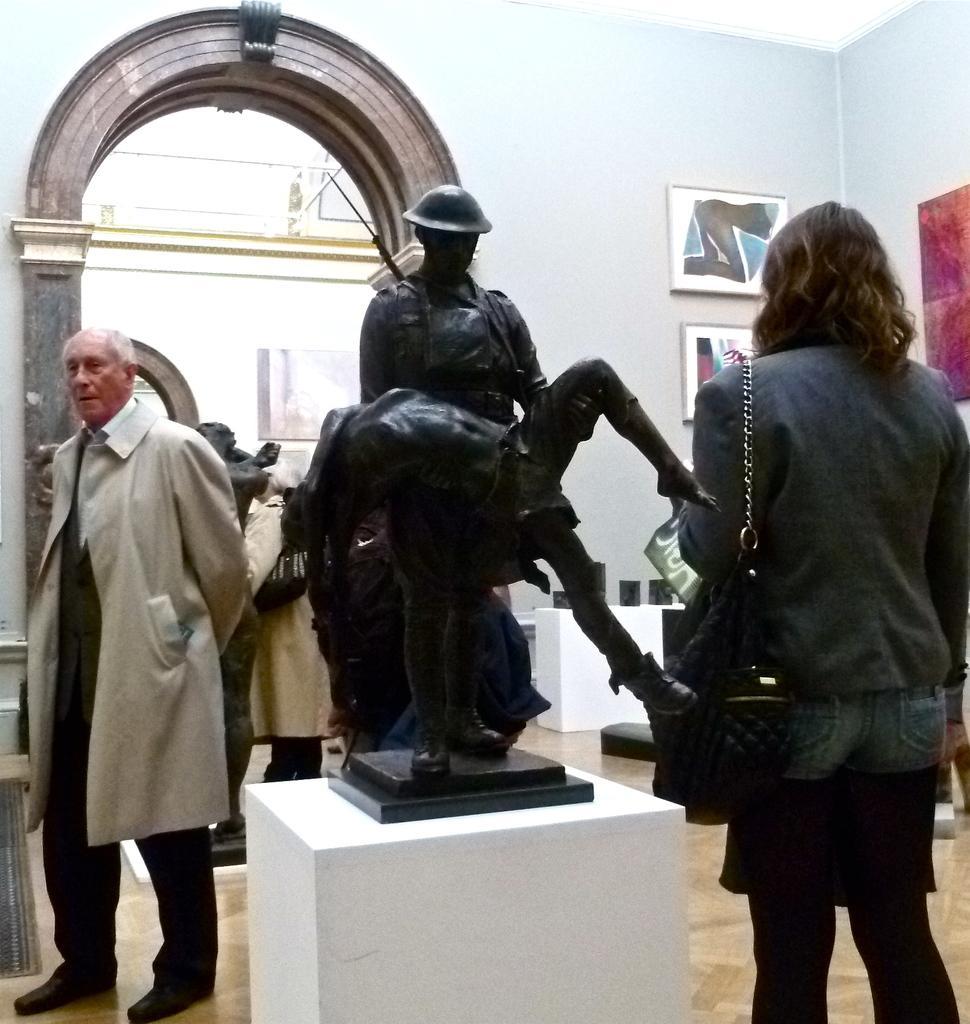In one or two sentences, can you explain what this image depicts? In the center of the image a sculpture is there. On the right side of the image a lady is standing and wearing a bag. On the left side of the image a man is there. In the background of the image we can see some photos, wall are present. At the bottom of the image floor is there. 